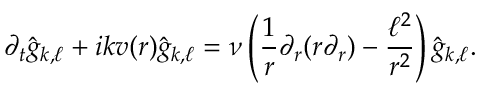<formula> <loc_0><loc_0><loc_500><loc_500>\partial _ { t } \hat { g } _ { k , \ell } + i k v ( r ) \hat { g } _ { k , \ell } = \nu \left ( \frac { 1 } { r } \partial _ { r } ( r \partial _ { r } ) - \frac { \ell ^ { 2 } } { r ^ { 2 } } \right ) \hat { g } _ { k , \ell } .</formula> 